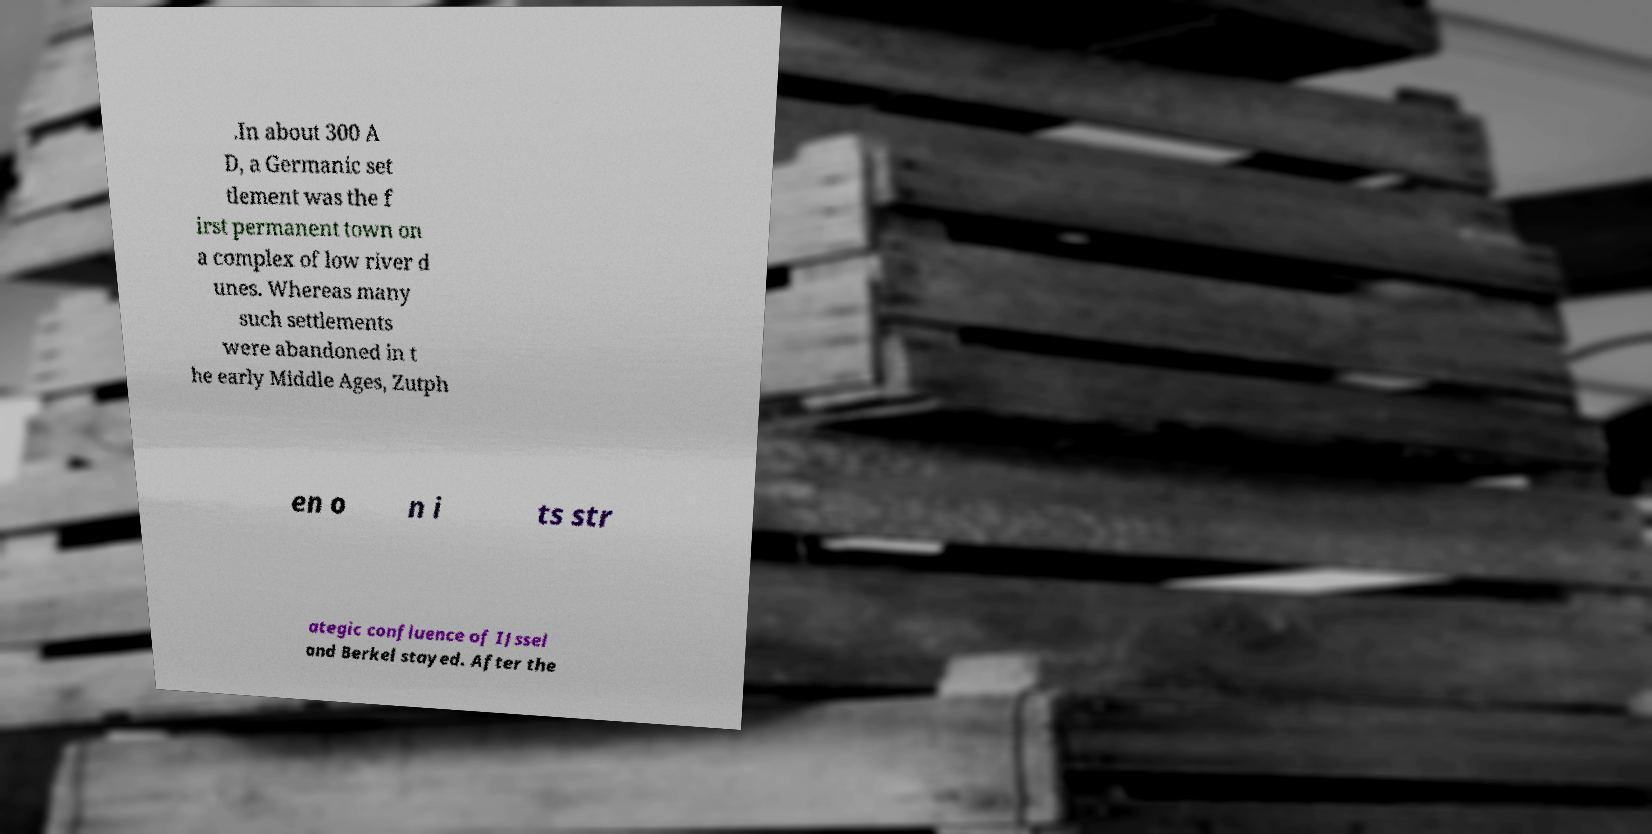Please identify and transcribe the text found in this image. .In about 300 A D, a Germanic set tlement was the f irst permanent town on a complex of low river d unes. Whereas many such settlements were abandoned in t he early Middle Ages, Zutph en o n i ts str ategic confluence of IJssel and Berkel stayed. After the 